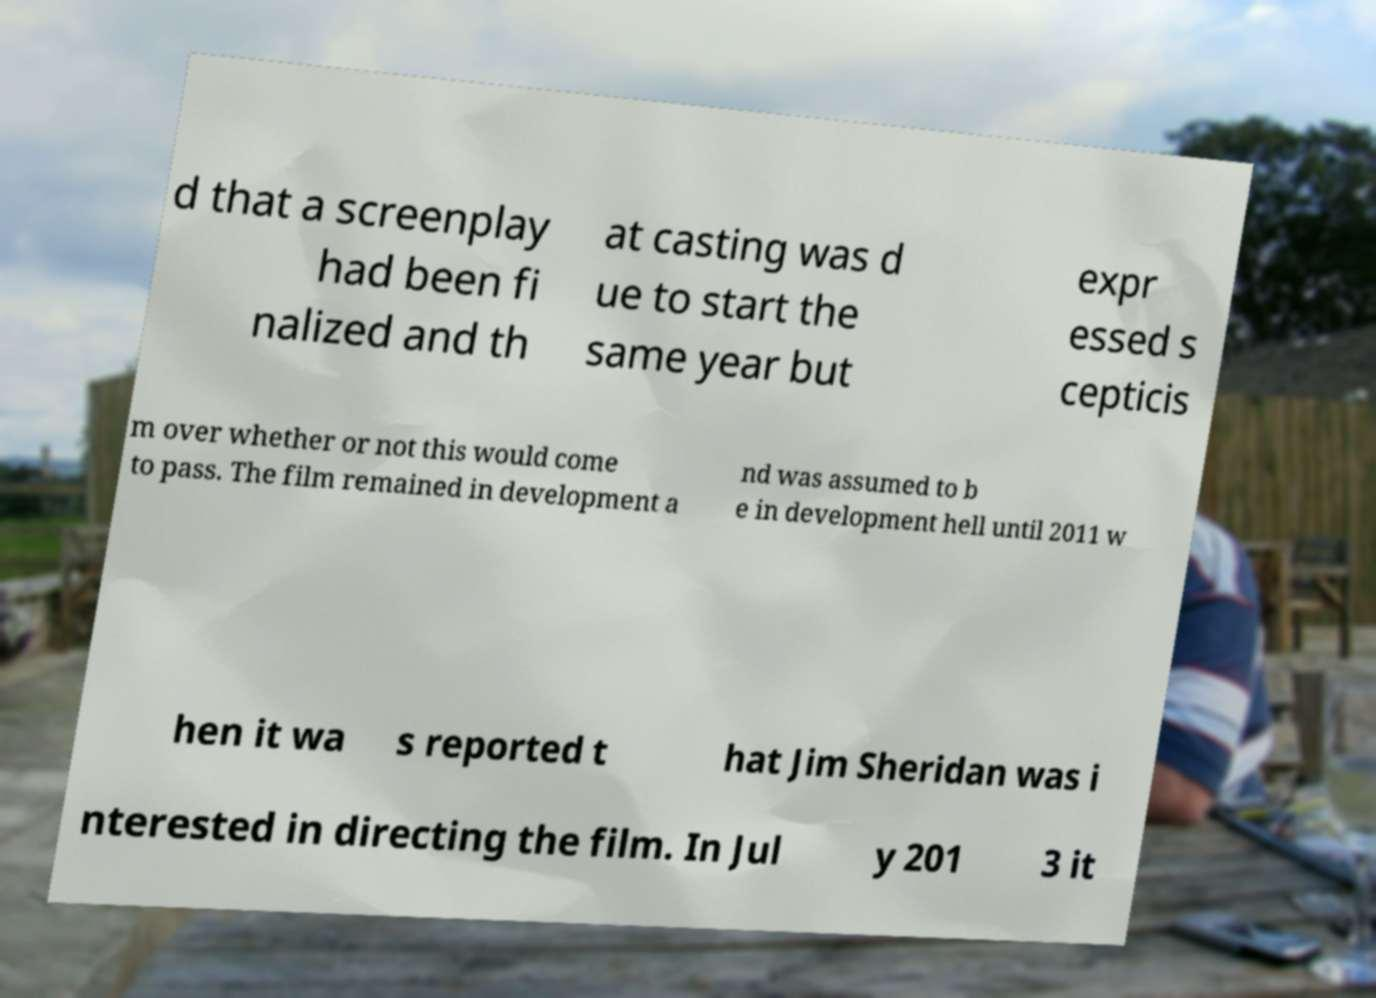Please identify and transcribe the text found in this image. d that a screenplay had been fi nalized and th at casting was d ue to start the same year but expr essed s cepticis m over whether or not this would come to pass. The film remained in development a nd was assumed to b e in development hell until 2011 w hen it wa s reported t hat Jim Sheridan was i nterested in directing the film. In Jul y 201 3 it 